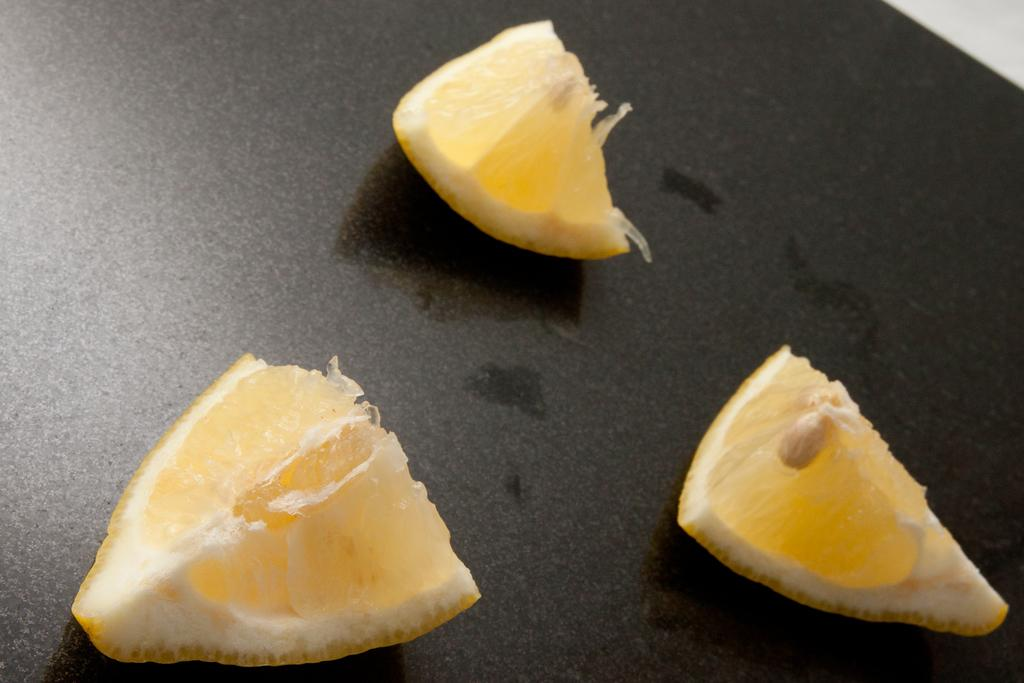What is the main subject of the image? The main subject of the image is three pieces of lemon. What is the color of the surface on which the lemon pieces are placed? The lemon pieces are placed on a black surface. Are there any differences between the lemon pieces? Yes, the lemon pieces on the right have seeds. What direction are the lemon pieces facing in the image? The lemon pieces are not facing any specific direction; they are simply placed on the black surface. How many connections can be seen between the lemon pieces in the image? There are no connections between the lemon pieces in the image. 